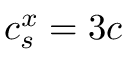<formula> <loc_0><loc_0><loc_500><loc_500>c _ { s } ^ { x } = 3 c</formula> 